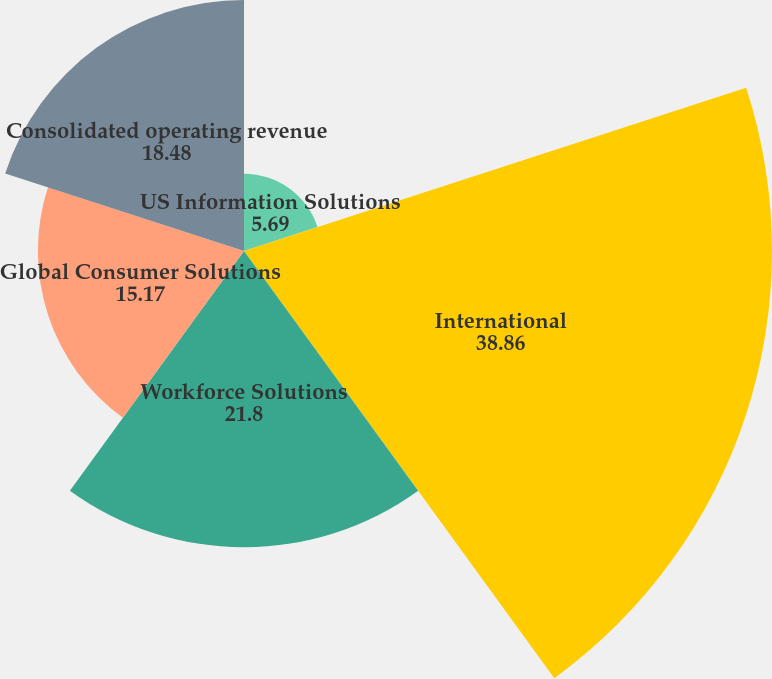Convert chart. <chart><loc_0><loc_0><loc_500><loc_500><pie_chart><fcel>US Information Solutions<fcel>International<fcel>Workforce Solutions<fcel>Global Consumer Solutions<fcel>Consolidated operating revenue<nl><fcel>5.69%<fcel>38.86%<fcel>21.8%<fcel>15.17%<fcel>18.48%<nl></chart> 